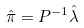<formula> <loc_0><loc_0><loc_500><loc_500>\hat { \pi } = P ^ { - 1 } \hat { \lambda }</formula> 